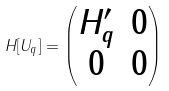<formula> <loc_0><loc_0><loc_500><loc_500>H [ U _ { q } ] = \begin{pmatrix} H _ { q } ^ { \prime } & 0 \\ 0 & 0 \end{pmatrix}</formula> 